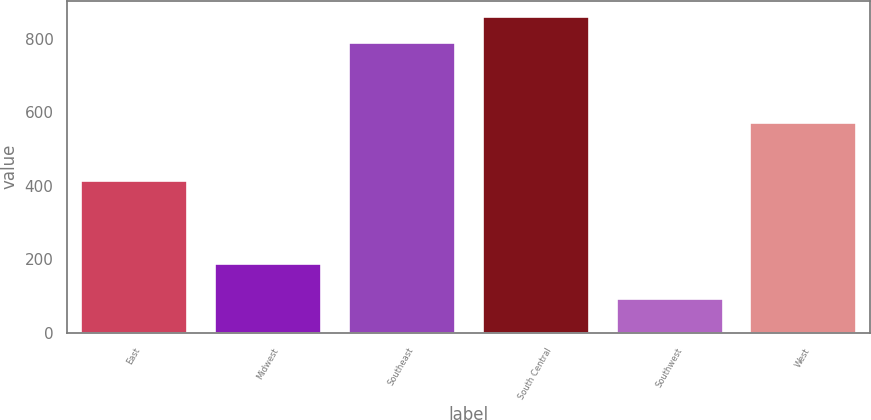Convert chart to OTSL. <chart><loc_0><loc_0><loc_500><loc_500><bar_chart><fcel>East<fcel>Midwest<fcel>Southeast<fcel>South Central<fcel>Southwest<fcel>West<nl><fcel>416.7<fcel>191.3<fcel>790.7<fcel>860.27<fcel>96<fcel>572.4<nl></chart> 